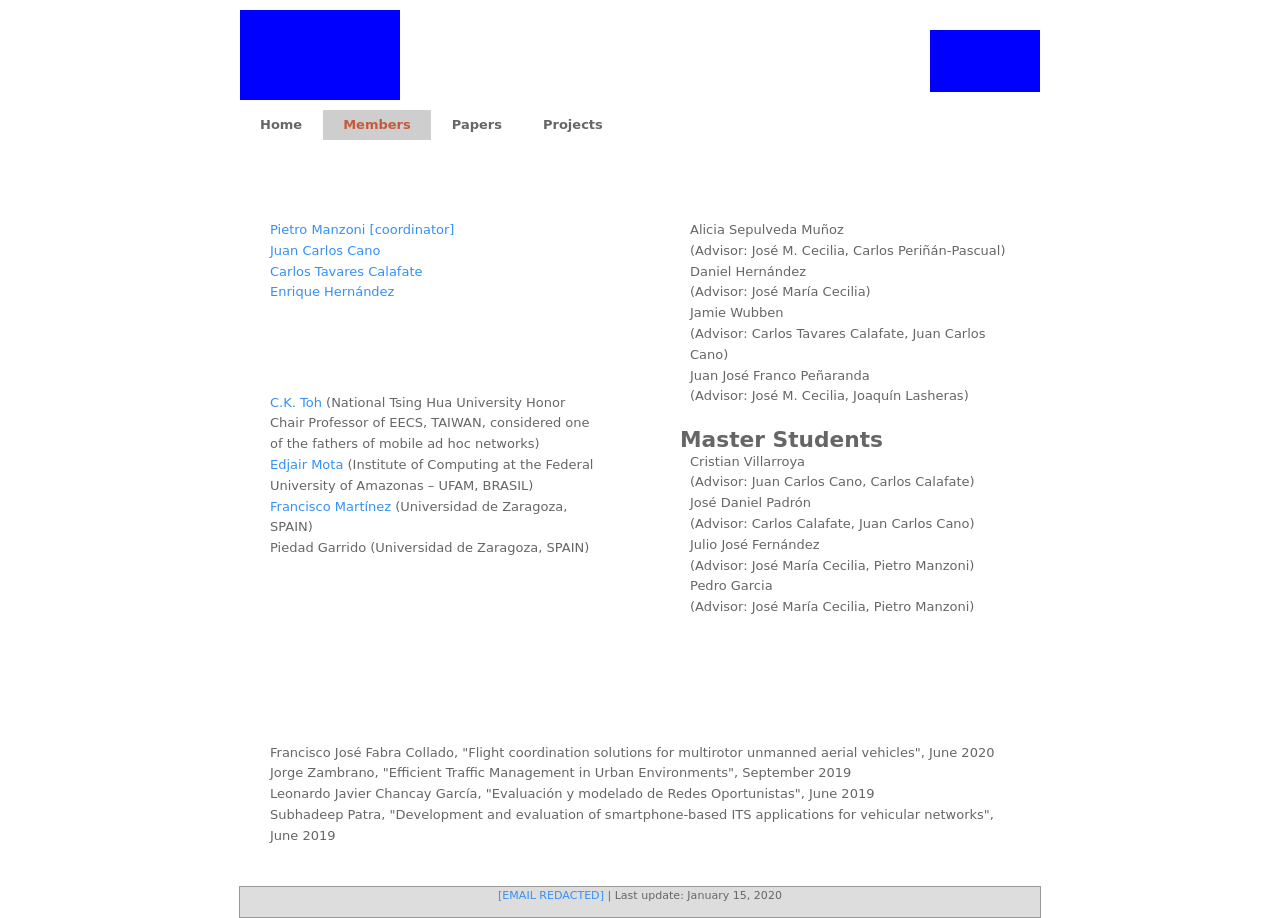Can you tell me about any significant achievements of the faculty members listed here? Members of the faculty like C.K. Toh are highly recognized, notably having a chair professorship and being considered a pioneer in mobile ad hoc networks. Other faculty members are probably involved in significant research on topics like ITS applications for vehicular networks or enhancing the network capabilities for better performance in varied environments. 